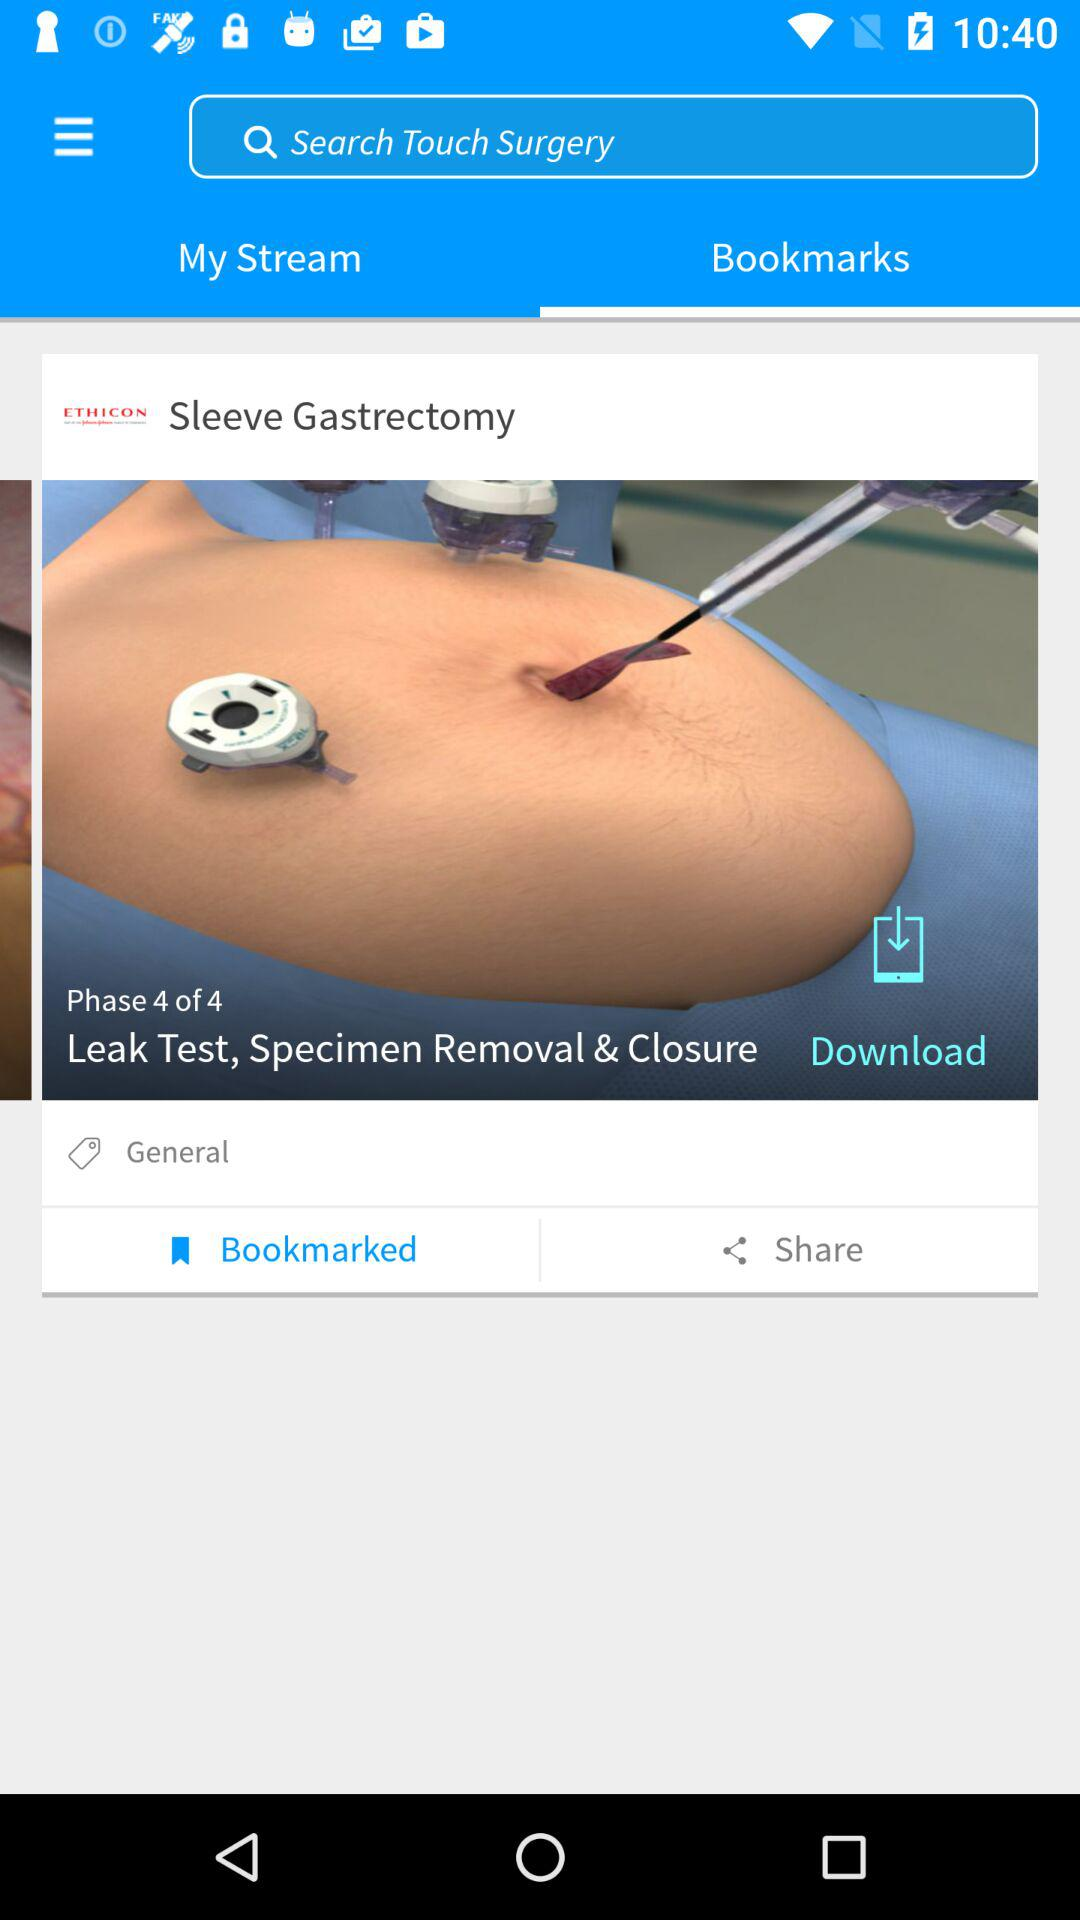How many phases in total are there? There are 4 phases in total. 